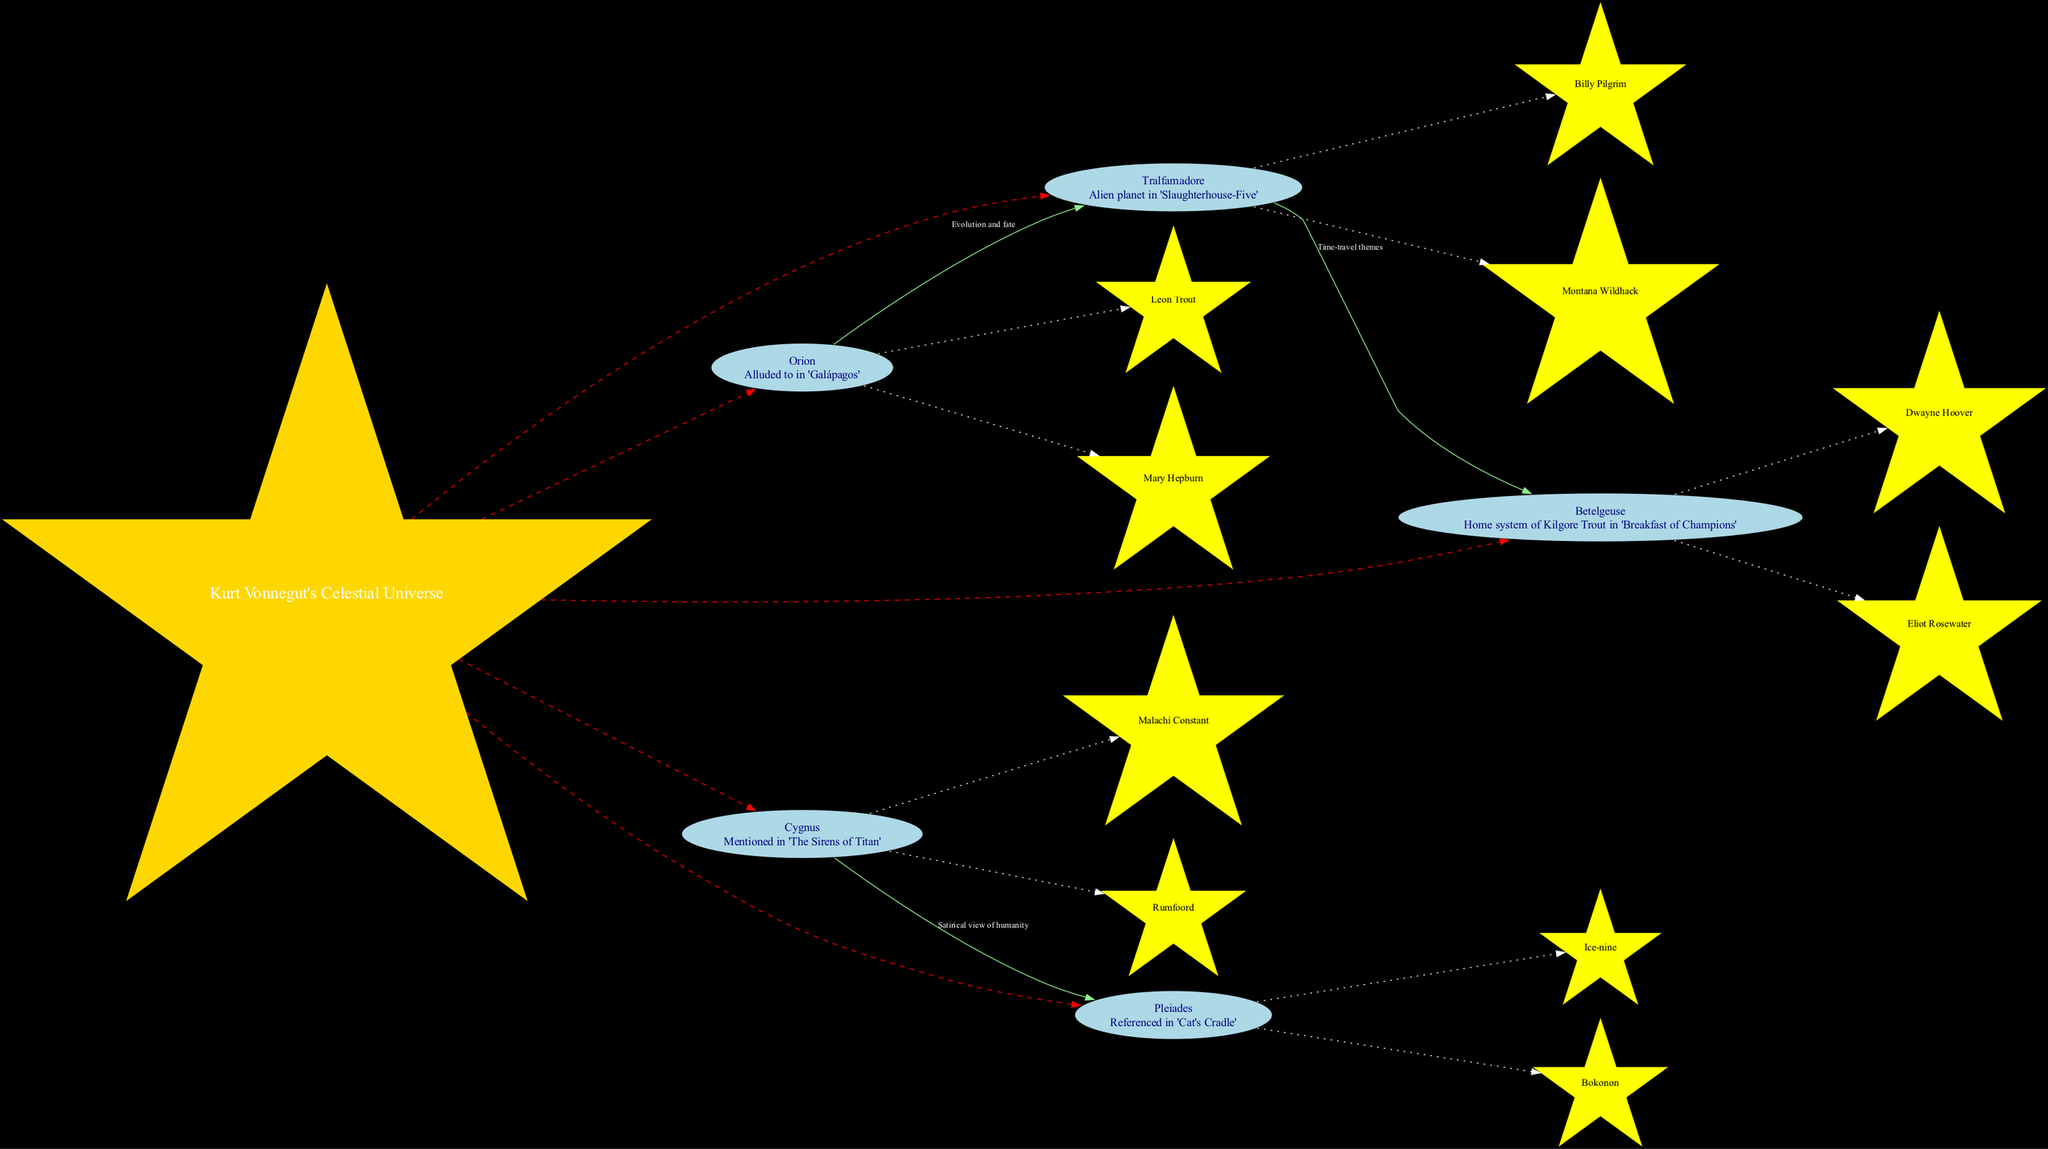What is the center of the diagram? The diagram's center is specified as "Kurt Vonnegut's Celestial Universe". This is the focus around which all constellations are organized, visually indicating the thematic significance of vonnegut's works in relation to the universe.
Answer: Kurt Vonnegut's Celestial Universe How many constellations are represented in the diagram? By counting the individual sections labeled as constellations in the diagram, we identify that there are five labeled constellations.
Answer: 5 Which constellation is associated with the significance of "Alien planet in 'Slaughterhouse-Five'"? The constellation labeled "Tralfamadore" has the description "Alien planet in 'Slaughterhouse-Five'" prominently displayed within the node, clearly indicating its significance to that work.
Answer: Tralfamadore What is the relationship between "Tralfamadore" and "Betelgeuse"? The edge connecting "Tralfamadore" to "Betelgeuse" is labeled "Time-travel themes", indicating a thematic connection between the two, specifically relating to the treatment of time in Vonnegut's narratives.
Answer: Time-travel themes Which stars are connected to the constellation "Pleiades"? Within the "Pleiades" node, the stars labeled are "Ice-nine" and "Bokonon", which are mentioned in relation to this constellation in Vonnegut's works.
Answer: Ice-nine, Bokonon How many connections are shown between constellations in the diagram? By examining the edges that connect different constellations, we can count three distinct connections indicated between them in the diagram.
Answer: 3 What stars are directly linked to the "Cygnus" constellation? Within the information provided about "Cygnus", the stars connected to this constellation are "Malachi Constant" and "Rumfoord", which are explicitly mentioned in the diagram.
Answer: Malachi Constant, Rumfoord Which constellation connects "Orion" and "Tralfamadore"? The edge labeled "Evolution and fate" visually represents the connection between "Orion" and "Tralfamadore", indicating a thematic link between these two constellations.
Answer: Evolution and fate What color is the center node of the diagram? The center node is filled with a gold color, which is specified in the diagram attributes for the node representing the central theme of Kurt Vonnegut's works.
Answer: Gold 